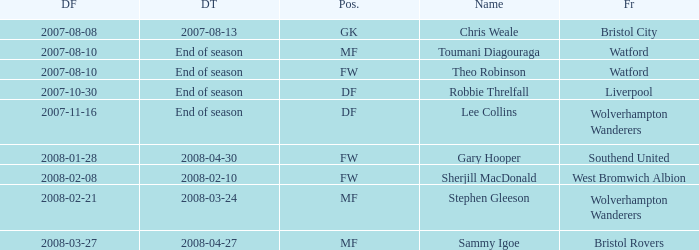What date did Toumani Diagouraga, who played position MF, start? 2007-08-10. 